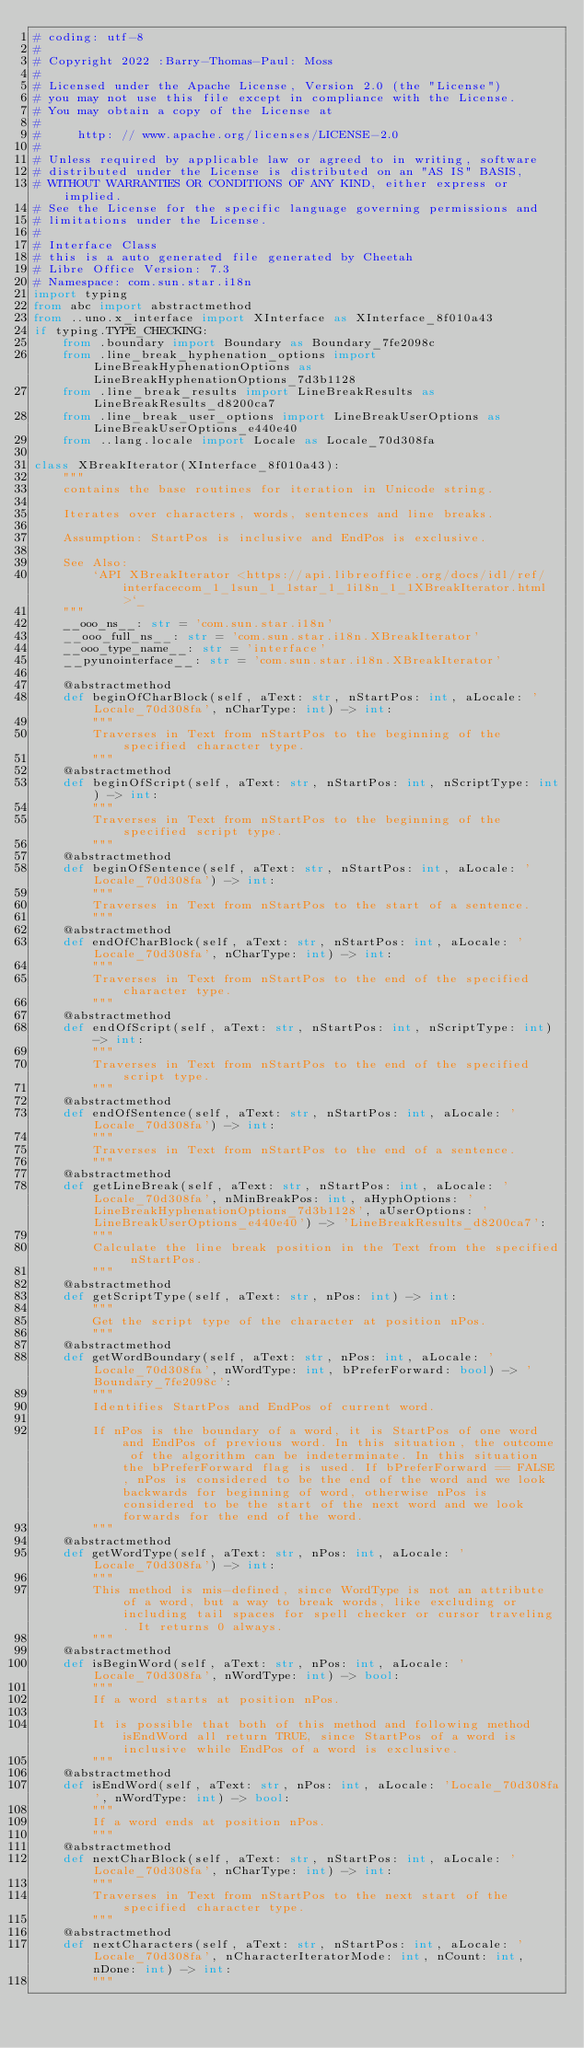Convert code to text. <code><loc_0><loc_0><loc_500><loc_500><_Python_># coding: utf-8
#
# Copyright 2022 :Barry-Thomas-Paul: Moss
#
# Licensed under the Apache License, Version 2.0 (the "License")
# you may not use this file except in compliance with the License.
# You may obtain a copy of the License at
#
#     http: // www.apache.org/licenses/LICENSE-2.0
#
# Unless required by applicable law or agreed to in writing, software
# distributed under the License is distributed on an "AS IS" BASIS,
# WITHOUT WARRANTIES OR CONDITIONS OF ANY KIND, either express or implied.
# See the License for the specific language governing permissions and
# limitations under the License.
#
# Interface Class
# this is a auto generated file generated by Cheetah
# Libre Office Version: 7.3
# Namespace: com.sun.star.i18n
import typing
from abc import abstractmethod
from ..uno.x_interface import XInterface as XInterface_8f010a43
if typing.TYPE_CHECKING:
    from .boundary import Boundary as Boundary_7fe2098c
    from .line_break_hyphenation_options import LineBreakHyphenationOptions as LineBreakHyphenationOptions_7d3b1128
    from .line_break_results import LineBreakResults as LineBreakResults_d8200ca7
    from .line_break_user_options import LineBreakUserOptions as LineBreakUserOptions_e440e40
    from ..lang.locale import Locale as Locale_70d308fa

class XBreakIterator(XInterface_8f010a43):
    """
    contains the base routines for iteration in Unicode string.
    
    Iterates over characters, words, sentences and line breaks.
    
    Assumption: StartPos is inclusive and EndPos is exclusive.

    See Also:
        `API XBreakIterator <https://api.libreoffice.org/docs/idl/ref/interfacecom_1_1sun_1_1star_1_1i18n_1_1XBreakIterator.html>`_
    """
    __ooo_ns__: str = 'com.sun.star.i18n'
    __ooo_full_ns__: str = 'com.sun.star.i18n.XBreakIterator'
    __ooo_type_name__: str = 'interface'
    __pyunointerface__: str = 'com.sun.star.i18n.XBreakIterator'

    @abstractmethod
    def beginOfCharBlock(self, aText: str, nStartPos: int, aLocale: 'Locale_70d308fa', nCharType: int) -> int:
        """
        Traverses in Text from nStartPos to the beginning of the specified character type.
        """
    @abstractmethod
    def beginOfScript(self, aText: str, nStartPos: int, nScriptType: int) -> int:
        """
        Traverses in Text from nStartPos to the beginning of the specified script type.
        """
    @abstractmethod
    def beginOfSentence(self, aText: str, nStartPos: int, aLocale: 'Locale_70d308fa') -> int:
        """
        Traverses in Text from nStartPos to the start of a sentence.
        """
    @abstractmethod
    def endOfCharBlock(self, aText: str, nStartPos: int, aLocale: 'Locale_70d308fa', nCharType: int) -> int:
        """
        Traverses in Text from nStartPos to the end of the specified character type.
        """
    @abstractmethod
    def endOfScript(self, aText: str, nStartPos: int, nScriptType: int) -> int:
        """
        Traverses in Text from nStartPos to the end of the specified script type.
        """
    @abstractmethod
    def endOfSentence(self, aText: str, nStartPos: int, aLocale: 'Locale_70d308fa') -> int:
        """
        Traverses in Text from nStartPos to the end of a sentence.
        """
    @abstractmethod
    def getLineBreak(self, aText: str, nStartPos: int, aLocale: 'Locale_70d308fa', nMinBreakPos: int, aHyphOptions: 'LineBreakHyphenationOptions_7d3b1128', aUserOptions: 'LineBreakUserOptions_e440e40') -> 'LineBreakResults_d8200ca7':
        """
        Calculate the line break position in the Text from the specified nStartPos.
        """
    @abstractmethod
    def getScriptType(self, aText: str, nPos: int) -> int:
        """
        Get the script type of the character at position nPos.
        """
    @abstractmethod
    def getWordBoundary(self, aText: str, nPos: int, aLocale: 'Locale_70d308fa', nWordType: int, bPreferForward: bool) -> 'Boundary_7fe2098c':
        """
        Identifies StartPos and EndPos of current word.
        
        If nPos is the boundary of a word, it is StartPos of one word and EndPos of previous word. In this situation, the outcome of the algorithm can be indeterminate. In this situation the bPreferForward flag is used. If bPreferForward == FALSE, nPos is considered to be the end of the word and we look backwards for beginning of word, otherwise nPos is considered to be the start of the next word and we look forwards for the end of the word.
        """
    @abstractmethod
    def getWordType(self, aText: str, nPos: int, aLocale: 'Locale_70d308fa') -> int:
        """
        This method is mis-defined, since WordType is not an attribute of a word, but a way to break words, like excluding or including tail spaces for spell checker or cursor traveling. It returns 0 always.
        """
    @abstractmethod
    def isBeginWord(self, aText: str, nPos: int, aLocale: 'Locale_70d308fa', nWordType: int) -> bool:
        """
        If a word starts at position nPos.
        
        It is possible that both of this method and following method isEndWord all return TRUE, since StartPos of a word is inclusive while EndPos of a word is exclusive.
        """
    @abstractmethod
    def isEndWord(self, aText: str, nPos: int, aLocale: 'Locale_70d308fa', nWordType: int) -> bool:
        """
        If a word ends at position nPos.
        """
    @abstractmethod
    def nextCharBlock(self, aText: str, nStartPos: int, aLocale: 'Locale_70d308fa', nCharType: int) -> int:
        """
        Traverses in Text from nStartPos to the next start of the specified character type.
        """
    @abstractmethod
    def nextCharacters(self, aText: str, nStartPos: int, aLocale: 'Locale_70d308fa', nCharacterIteratorMode: int, nCount: int, nDone: int) -> int:
        """</code> 